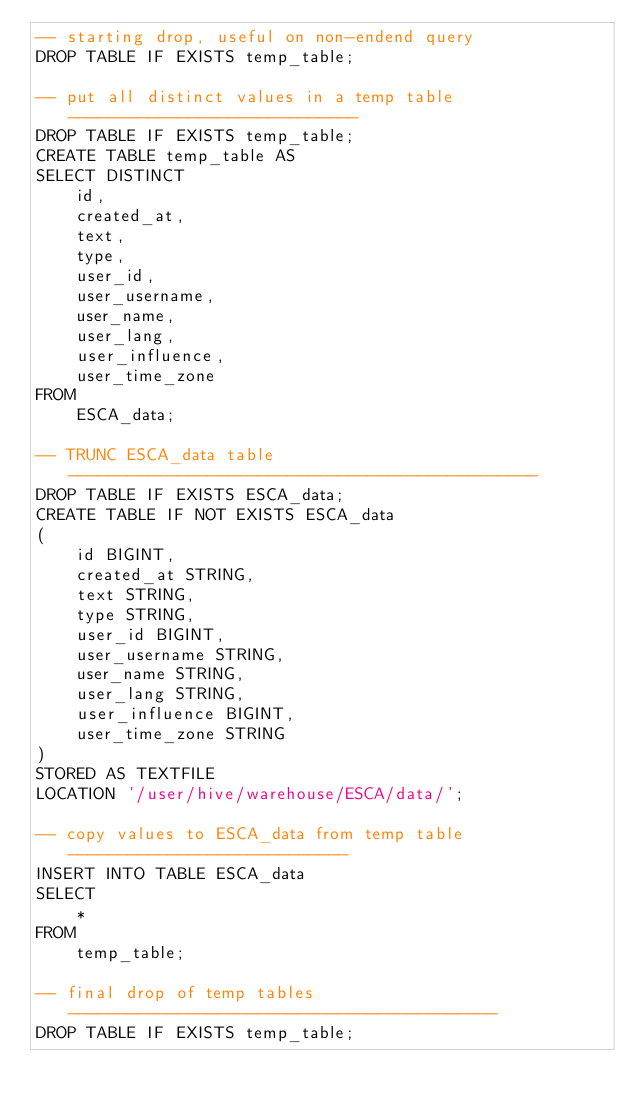<code> <loc_0><loc_0><loc_500><loc_500><_SQL_>-- starting drop, useful on non-endend query
DROP TABLE IF EXISTS temp_table;

-- put all distinct values in a temp table -----------------------------
DROP TABLE IF EXISTS temp_table;
CREATE TABLE temp_table AS
SELECT DISTINCT
	id,
	created_at,
	text,
	type,
	user_id,
	user_username,
	user_name,
	user_lang,
	user_influence,
	user_time_zone
FROM
	ESCA_data;

-- TRUNC ESCA_data table -----------------------------------------------
DROP TABLE IF EXISTS ESCA_data;
CREATE TABLE IF NOT EXISTS ESCA_data
(
	id BIGINT,
	created_at STRING,
	text STRING,
	type STRING,
	user_id BIGINT,
	user_username STRING,
	user_name STRING,
	user_lang STRING,
	user_influence BIGINT,
	user_time_zone STRING
)
STORED AS TEXTFILE
LOCATION '/user/hive/warehouse/ESCA/data/';

-- copy values to ESCA_data from temp table ----------------------------
INSERT INTO TABLE ESCA_data
SELECT
	*
FROM
	temp_table;
	
-- final drop of temp tables -------------------------------------------
DROP TABLE IF EXISTS temp_table;
</code> 